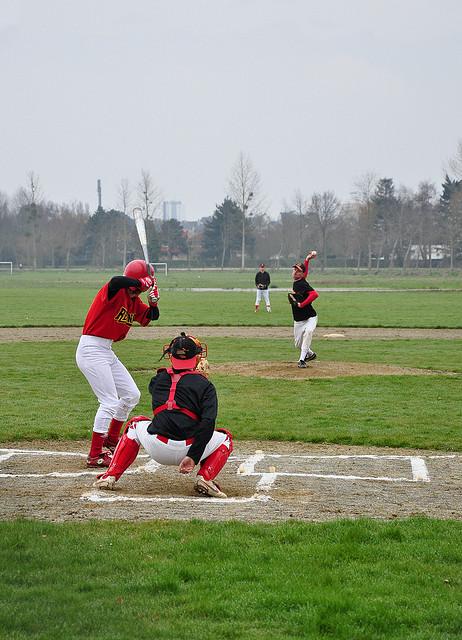What sport is this?
Quick response, please. Baseball. What position is shown behind the batter?
Answer briefly. Catcher. How many blades of grass are in this field?
Quick response, please. Millions. What is the boy with the bat doing?
Quick response, please. Playing baseball. 